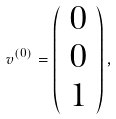Convert formula to latex. <formula><loc_0><loc_0><loc_500><loc_500>v ^ { ( 0 ) } = \left ( \begin{array} { c c c } { 0 } \\ { 0 } \\ 1 \end{array} \right ) ,</formula> 